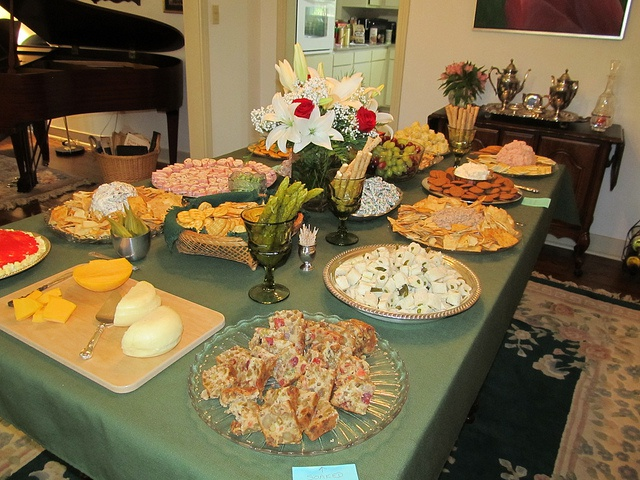Describe the objects in this image and their specific colors. I can see dining table in black, gray, tan, and darkgreen tones, sandwich in black, tan, brown, and gray tones, potted plant in black, brown, olive, and tan tones, wine glass in black, olive, and orange tones, and oven in black, beige, darkgray, and gray tones in this image. 